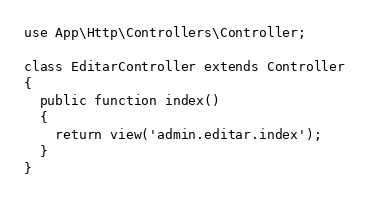Convert code to text. <code><loc_0><loc_0><loc_500><loc_500><_PHP_>use App\Http\Controllers\Controller;

class EditarController extends Controller
{
  public function index()
  {
    return view('admin.editar.index');
  }
}
</code> 